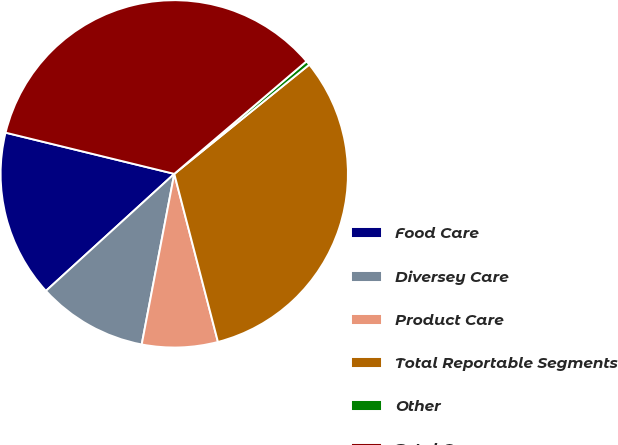<chart> <loc_0><loc_0><loc_500><loc_500><pie_chart><fcel>Food Care<fcel>Diversey Care<fcel>Product Care<fcel>Total Reportable Segments<fcel>Other<fcel>Total Company<nl><fcel>15.58%<fcel>10.23%<fcel>7.05%<fcel>31.78%<fcel>0.4%<fcel>34.96%<nl></chart> 